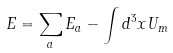Convert formula to latex. <formula><loc_0><loc_0><loc_500><loc_500>E = \sum _ { a } E _ { a } - \int d ^ { 3 } x U _ { m }</formula> 